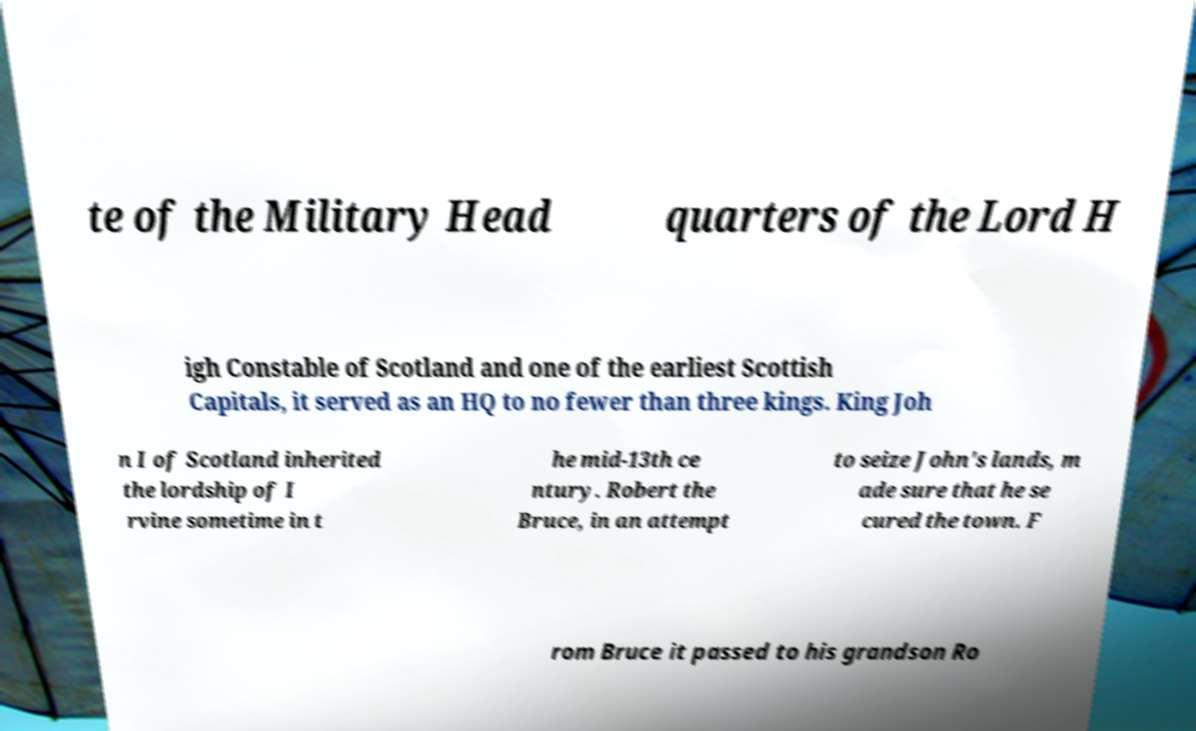Could you assist in decoding the text presented in this image and type it out clearly? te of the Military Head quarters of the Lord H igh Constable of Scotland and one of the earliest Scottish Capitals, it served as an HQ to no fewer than three kings. King Joh n I of Scotland inherited the lordship of I rvine sometime in t he mid-13th ce ntury. Robert the Bruce, in an attempt to seize John's lands, m ade sure that he se cured the town. F rom Bruce it passed to his grandson Ro 